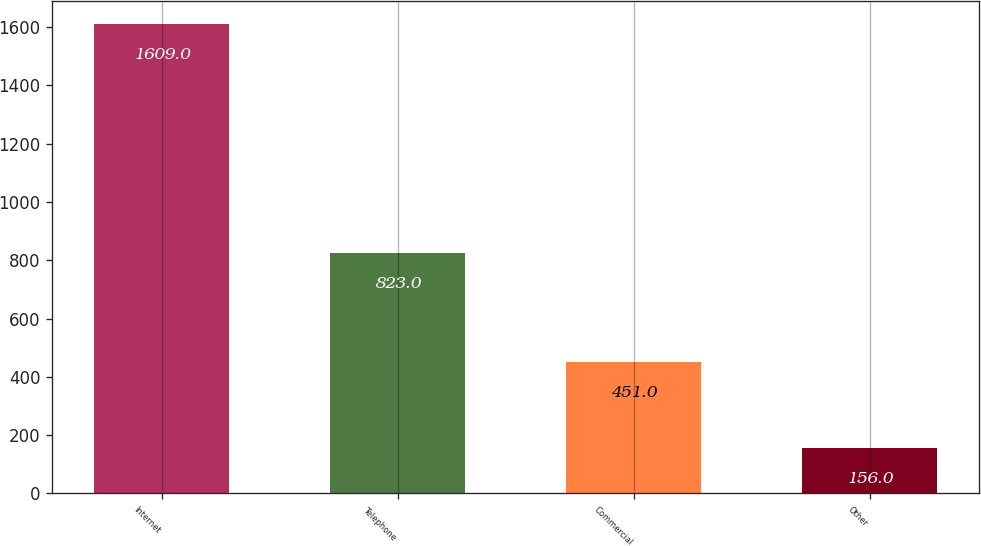Convert chart. <chart><loc_0><loc_0><loc_500><loc_500><bar_chart><fcel>Internet<fcel>Telephone<fcel>Commercial<fcel>Other<nl><fcel>1609<fcel>823<fcel>451<fcel>156<nl></chart> 